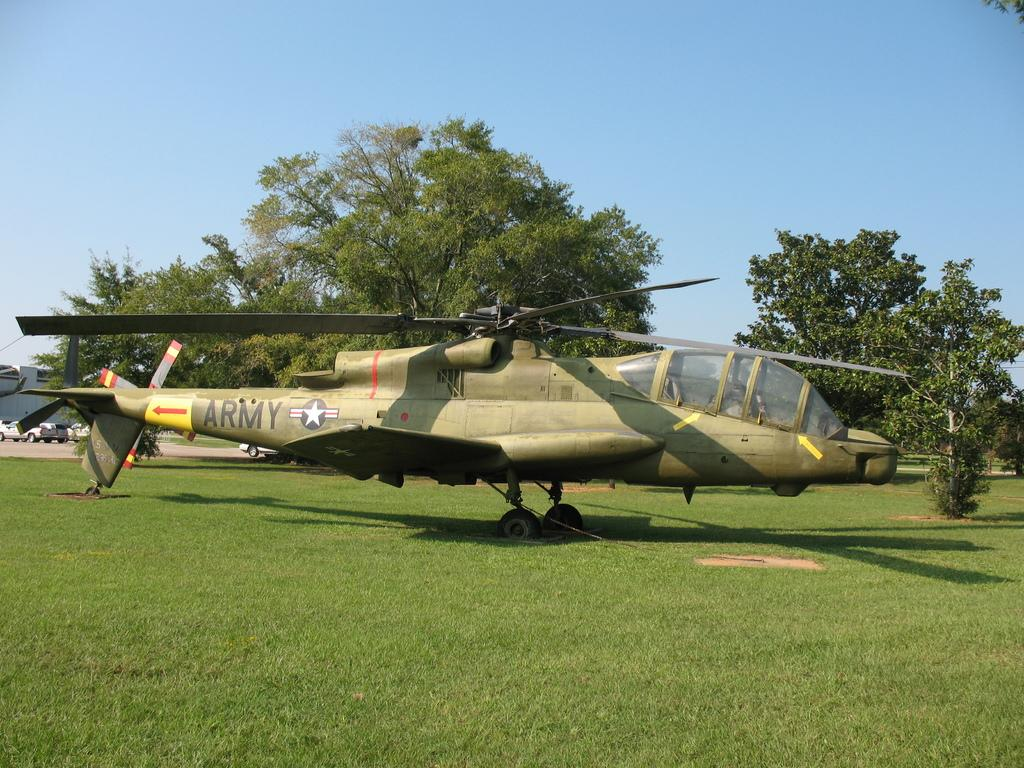<image>
Give a short and clear explanation of the subsequent image. An Army airplane is parked on a grassy field. 